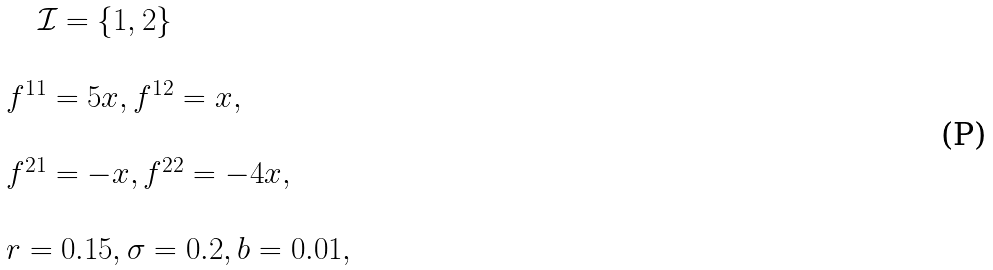Convert formula to latex. <formula><loc_0><loc_0><loc_500><loc_500>\begin{array} { l l } \quad \mathcal { I } = \{ 1 , 2 \} \\ \\ f ^ { 1 1 } = 5 x , f ^ { 1 2 } = x , \\ \\ f ^ { 2 1 } = - x , f ^ { 2 2 } = - 4 x , \\ \\ r = 0 . 1 5 , \sigma = 0 . 2 , b = 0 . 0 1 , \end{array}</formula> 